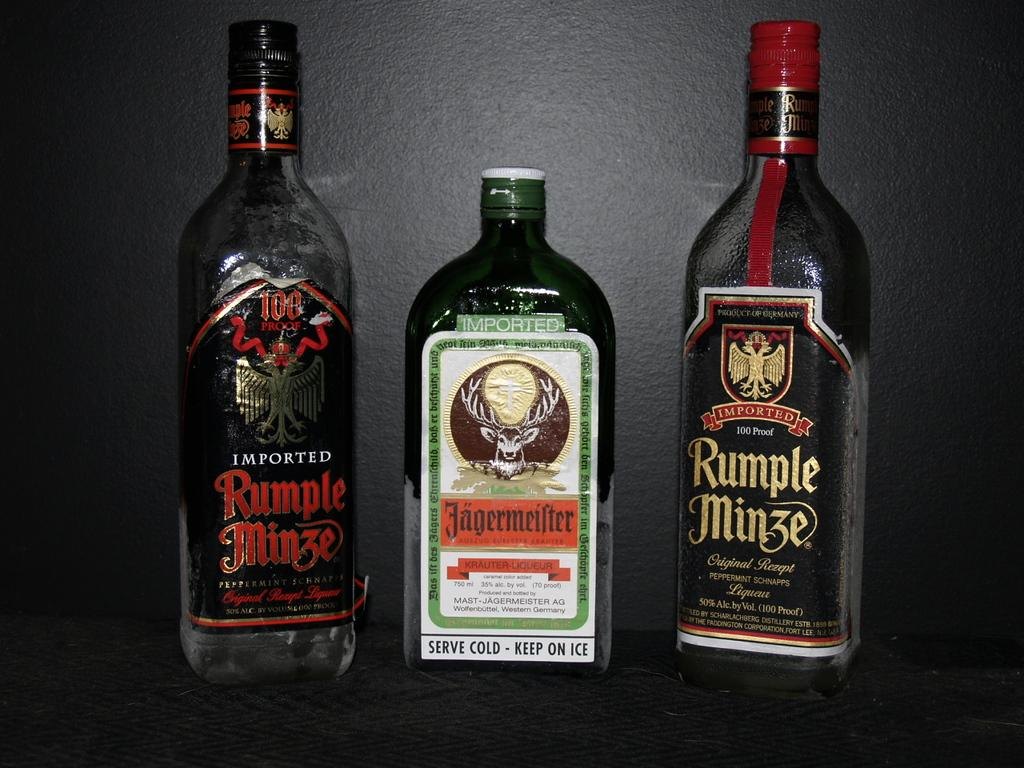<image>
Present a compact description of the photo's key features. Two red and one green bottle of imported alcoholic beverage 